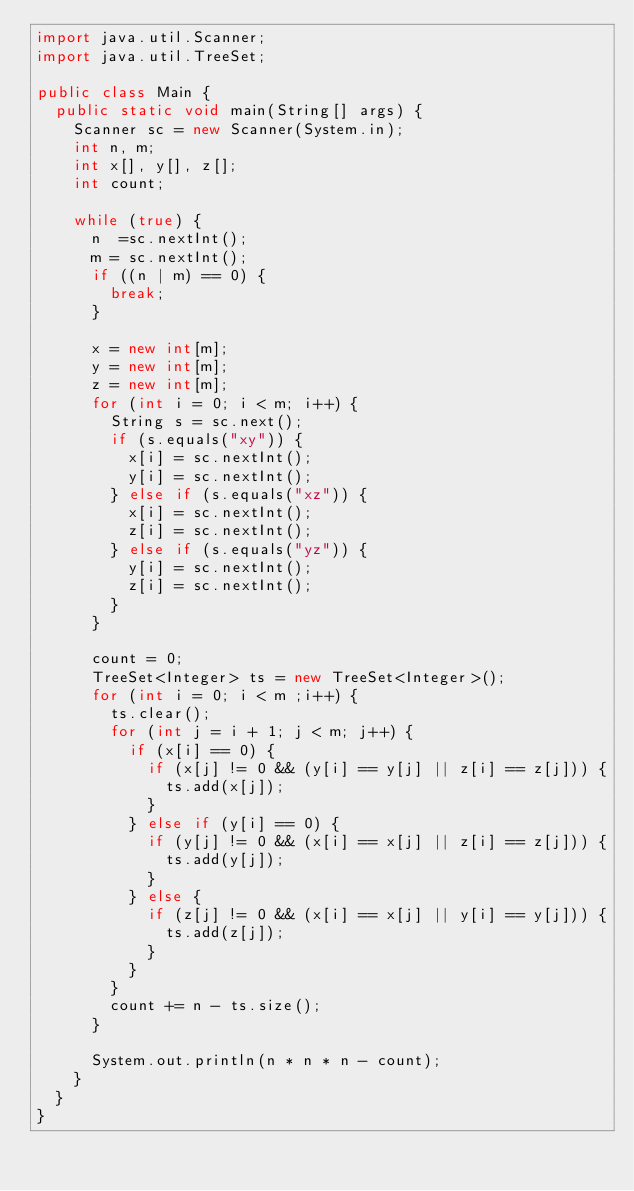<code> <loc_0><loc_0><loc_500><loc_500><_Java_>import java.util.Scanner;
import java.util.TreeSet;

public class Main {
	public static void main(String[] args) {
		Scanner sc = new Scanner(System.in);
		int n, m;
		int x[], y[], z[];
		int count;

		while (true) {
			n  =sc.nextInt();
			m = sc.nextInt();
			if ((n | m) == 0) {
				break;
			}

			x = new int[m];
			y = new int[m];
			z = new int[m];
			for (int i = 0; i < m; i++) {
				String s = sc.next();
				if (s.equals("xy")) {
					x[i] = sc.nextInt();
					y[i] = sc.nextInt();
				} else if (s.equals("xz")) {
					x[i] = sc.nextInt();
					z[i] = sc.nextInt();
				} else if (s.equals("yz")) {
					y[i] = sc.nextInt();
					z[i] = sc.nextInt();
				}
			}

			count = 0;
			TreeSet<Integer> ts = new TreeSet<Integer>();
			for (int i = 0; i < m ;i++) {
				ts.clear();
				for (int j = i + 1; j < m; j++) {
					if (x[i] == 0) {
						if (x[j] != 0 && (y[i] == y[j] || z[i] == z[j])) {
							ts.add(x[j]);
						}
					} else if (y[i] == 0) {
						if (y[j] != 0 && (x[i] == x[j] || z[i] == z[j])) {
							ts.add(y[j]);
						}
					} else {
						if (z[j] != 0 && (x[i] == x[j] || y[i] == y[j])) {
							ts.add(z[j]);
						}
					}
				}
				count += n - ts.size();
			}
			
			System.out.println(n * n * n - count);
		}
	}
}</code> 